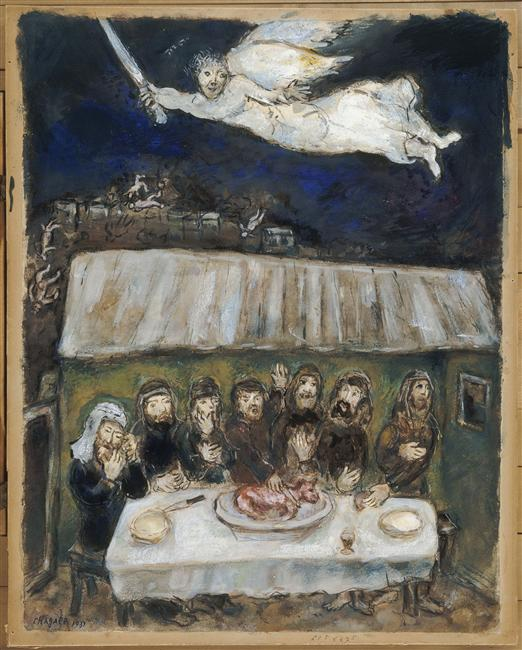Can you describe the main features of this image for me? The image portrays a surreal scene filled with symbolic elements. It features a gathering of several people around a table, which holds a large piece of meat at its center. The setting is primarily dark, with shades of black and deep blue, but it is highlighted by the stark white and light blue accents that bring a visual contrast. The people gathered appear focused and somewhat solemn, possibly indicating a significant event or ritual. Above the group, an angelic figure is depicted in flight, clutching a sword, adding a fantastical and divine element to the scene. This image exemplifies a blend of expressionism and surrealism, using both ordinary and otherworldly components to evoke mystery and invite deeper interpretation. 